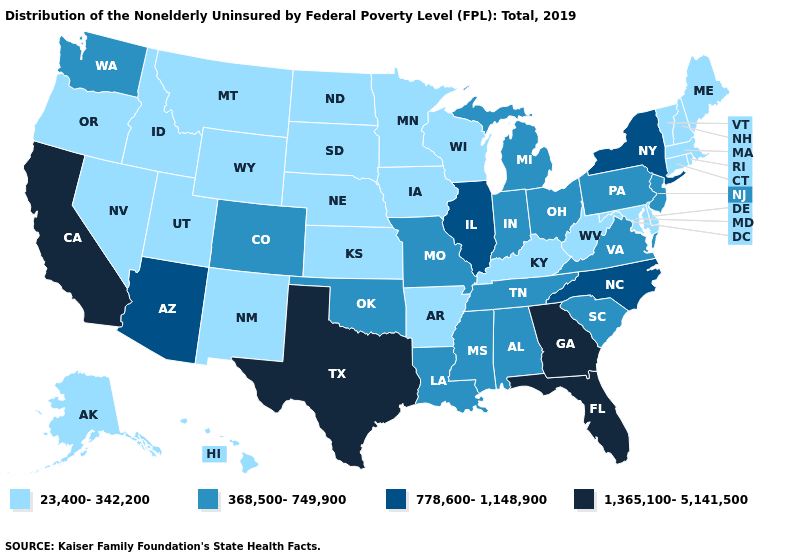How many symbols are there in the legend?
Concise answer only. 4. Does the first symbol in the legend represent the smallest category?
Write a very short answer. Yes. What is the lowest value in states that border New Hampshire?
Concise answer only. 23,400-342,200. Name the states that have a value in the range 778,600-1,148,900?
Write a very short answer. Arizona, Illinois, New York, North Carolina. What is the highest value in the MidWest ?
Be succinct. 778,600-1,148,900. Name the states that have a value in the range 23,400-342,200?
Quick response, please. Alaska, Arkansas, Connecticut, Delaware, Hawaii, Idaho, Iowa, Kansas, Kentucky, Maine, Maryland, Massachusetts, Minnesota, Montana, Nebraska, Nevada, New Hampshire, New Mexico, North Dakota, Oregon, Rhode Island, South Dakota, Utah, Vermont, West Virginia, Wisconsin, Wyoming. What is the value of Missouri?
Quick response, please. 368,500-749,900. Does Illinois have the highest value in the USA?
Write a very short answer. No. How many symbols are there in the legend?
Give a very brief answer. 4. What is the value of Oklahoma?
Be succinct. 368,500-749,900. Does Alaska have the highest value in the USA?
Be succinct. No. Does North Carolina have a lower value than Florida?
Quick response, please. Yes. Does the first symbol in the legend represent the smallest category?
Concise answer only. Yes. What is the value of Michigan?
Write a very short answer. 368,500-749,900. 